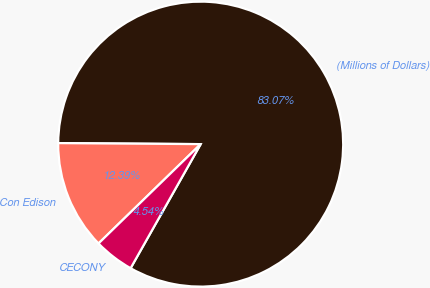Convert chart to OTSL. <chart><loc_0><loc_0><loc_500><loc_500><pie_chart><fcel>(Millions of Dollars)<fcel>Con Edison<fcel>CECONY<nl><fcel>83.06%<fcel>12.39%<fcel>4.54%<nl></chart> 